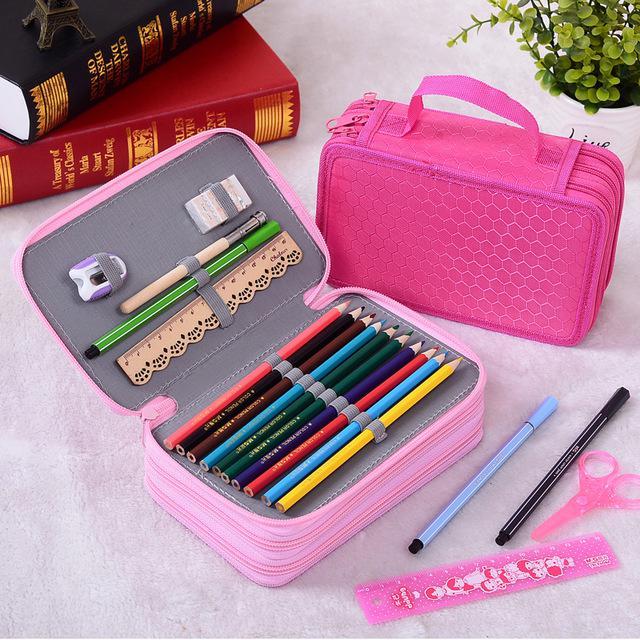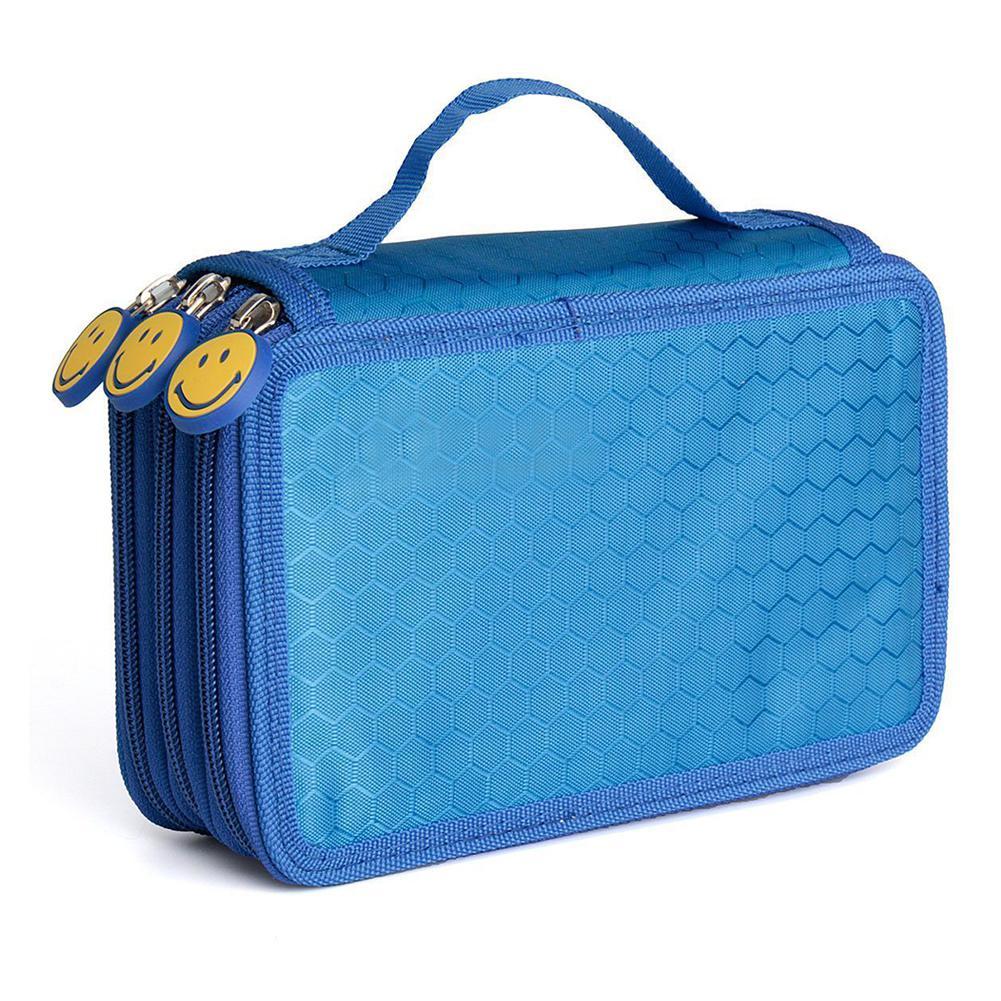The first image is the image on the left, the second image is the image on the right. Evaluate the accuracy of this statement regarding the images: "There are exactly three pencil cases.". Is it true? Answer yes or no. Yes. The first image is the image on the left, the second image is the image on the right. For the images displayed, is the sentence "An image features a bright pink case that is fanned open to reveal multiple sections holding a variety of writing implements." factually correct? Answer yes or no. No. 